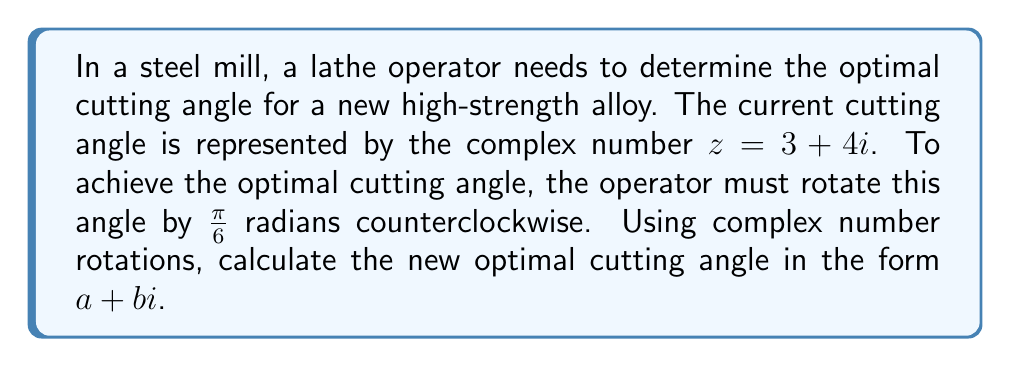Teach me how to tackle this problem. To solve this problem, we'll follow these steps:

1) Recall that to rotate a complex number $z$ by an angle $\theta$ counterclockwise, we multiply it by $e^{i\theta}$.

2) In this case, $z = 3 + 4i$ and $\theta = \frac{\pi}{6}$.

3) We need to calculate $z' = z \cdot e^{i\frac{\pi}{6}}$.

4) First, let's express $e^{i\frac{\pi}{6}}$ in the form $\cos\frac{\pi}{6} + i\sin\frac{\pi}{6}$:

   $e^{i\frac{\pi}{6}} = \cos\frac{\pi}{6} + i\sin\frac{\pi}{6} = \frac{\sqrt{3}}{2} + \frac{1}{2}i$

5) Now, let's multiply $z$ by this:

   $z' = (3 + 4i)(\frac{\sqrt{3}}{2} + \frac{1}{2}i)$

6) Expanding this:

   $z' = (3 \cdot \frac{\sqrt{3}}{2} - 4 \cdot \frac{1}{2}) + (3 \cdot \frac{1}{2} + 4 \cdot \frac{\sqrt{3}}{2})i$

7) Simplifying:

   $z' = (\frac{3\sqrt{3}}{2} - 2) + (\frac{3}{2} + 2\sqrt{3})i$

8) Further simplifying:

   $z' = (\frac{3\sqrt{3} - 4}{2}) + (\frac{3 + 4\sqrt{3}}{2})i$

This is the new optimal cutting angle in the form $a + bi$.
Answer: $(\frac{3\sqrt{3} - 4}{2}) + (\frac{3 + 4\sqrt{3}}{2})i$ 